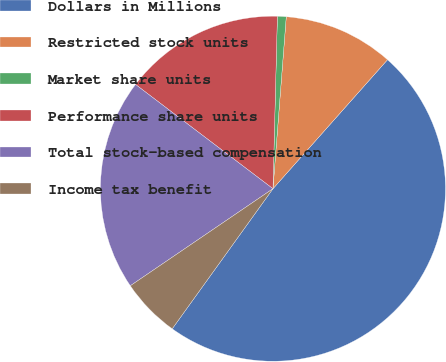Convert chart to OTSL. <chart><loc_0><loc_0><loc_500><loc_500><pie_chart><fcel>Dollars in Millions<fcel>Restricted stock units<fcel>Market share units<fcel>Performance share units<fcel>Total stock-based compensation<fcel>Income tax benefit<nl><fcel>48.37%<fcel>10.33%<fcel>0.82%<fcel>15.08%<fcel>19.84%<fcel>5.57%<nl></chart> 